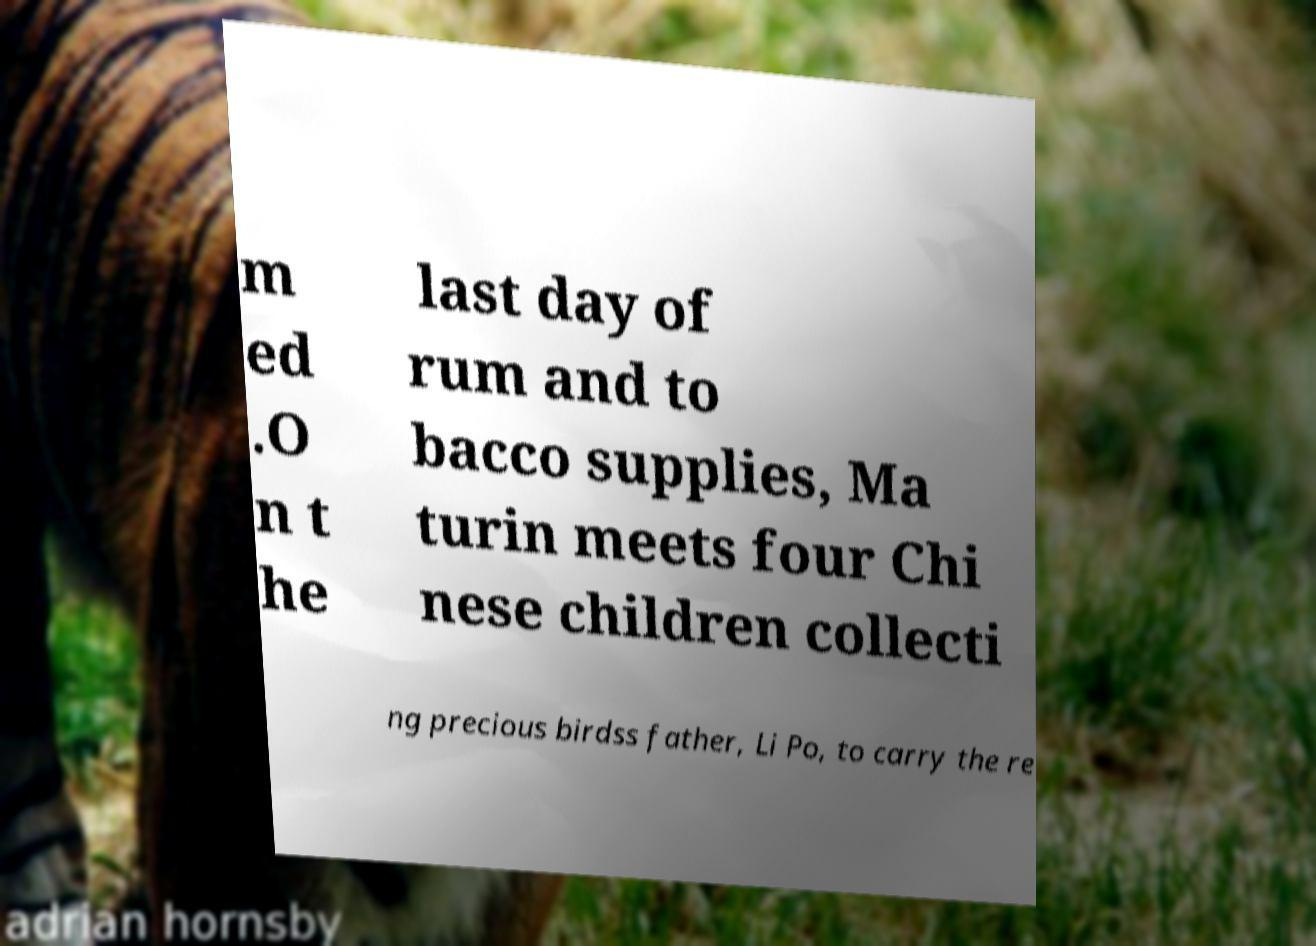Could you assist in decoding the text presented in this image and type it out clearly? m ed .O n t he last day of rum and to bacco supplies, Ma turin meets four Chi nese children collecti ng precious birdss father, Li Po, to carry the re 